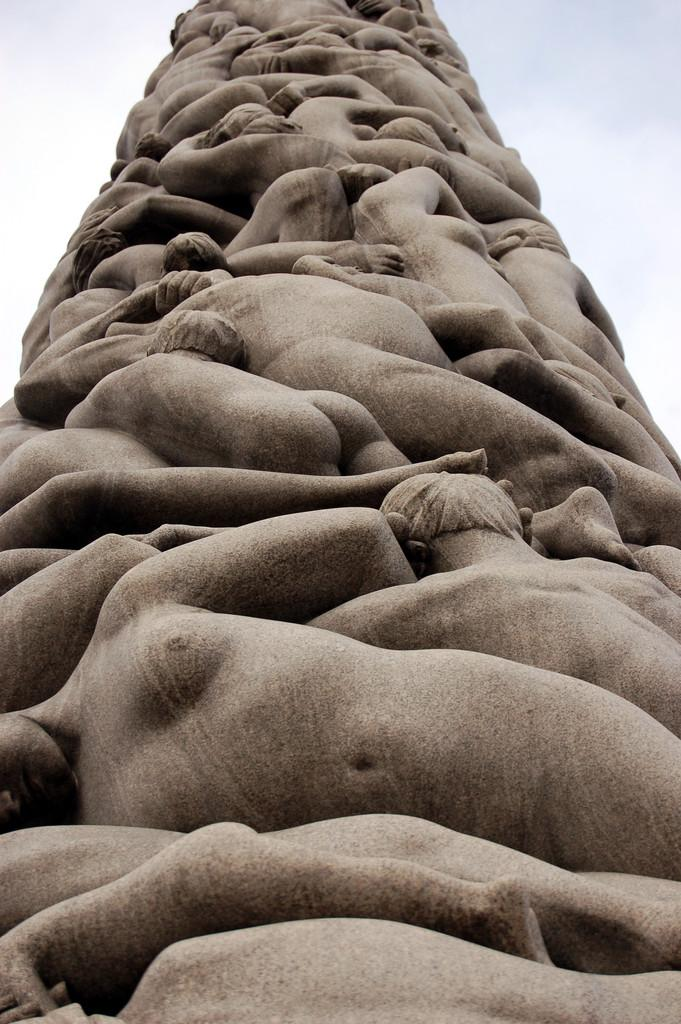What is the main subject of the image? There is a people sculpture in the image. What can be seen in the background of the image? The sky is visible in the background of the image. What type of appliance is being used by the people sculpture in the image? There is no appliance present in the image; it features a people sculpture and the sky in the background. What type of business is being conducted by the people sculpture in the image? There is no business activity depicted in the image; it features a people sculpture and the sky in the background. 